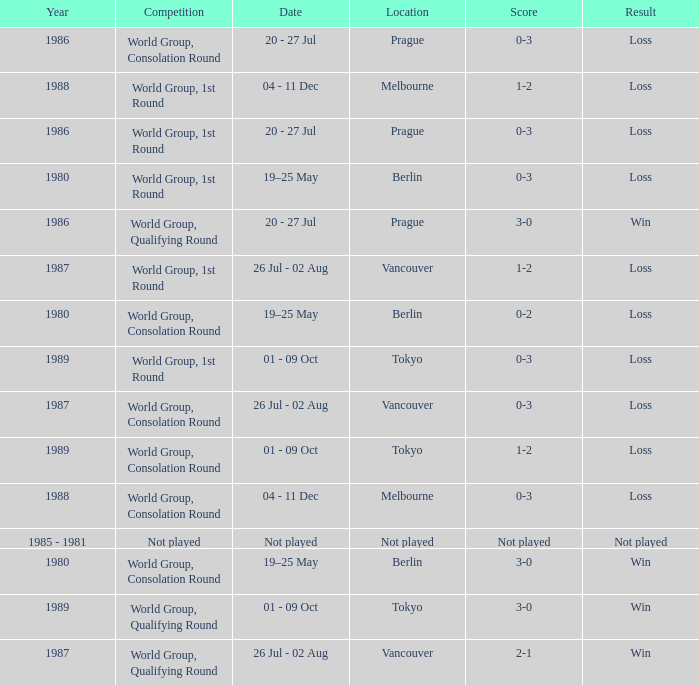What is the competition when the result is loss in berlin with a score of 0-3? World Group, 1st Round. 